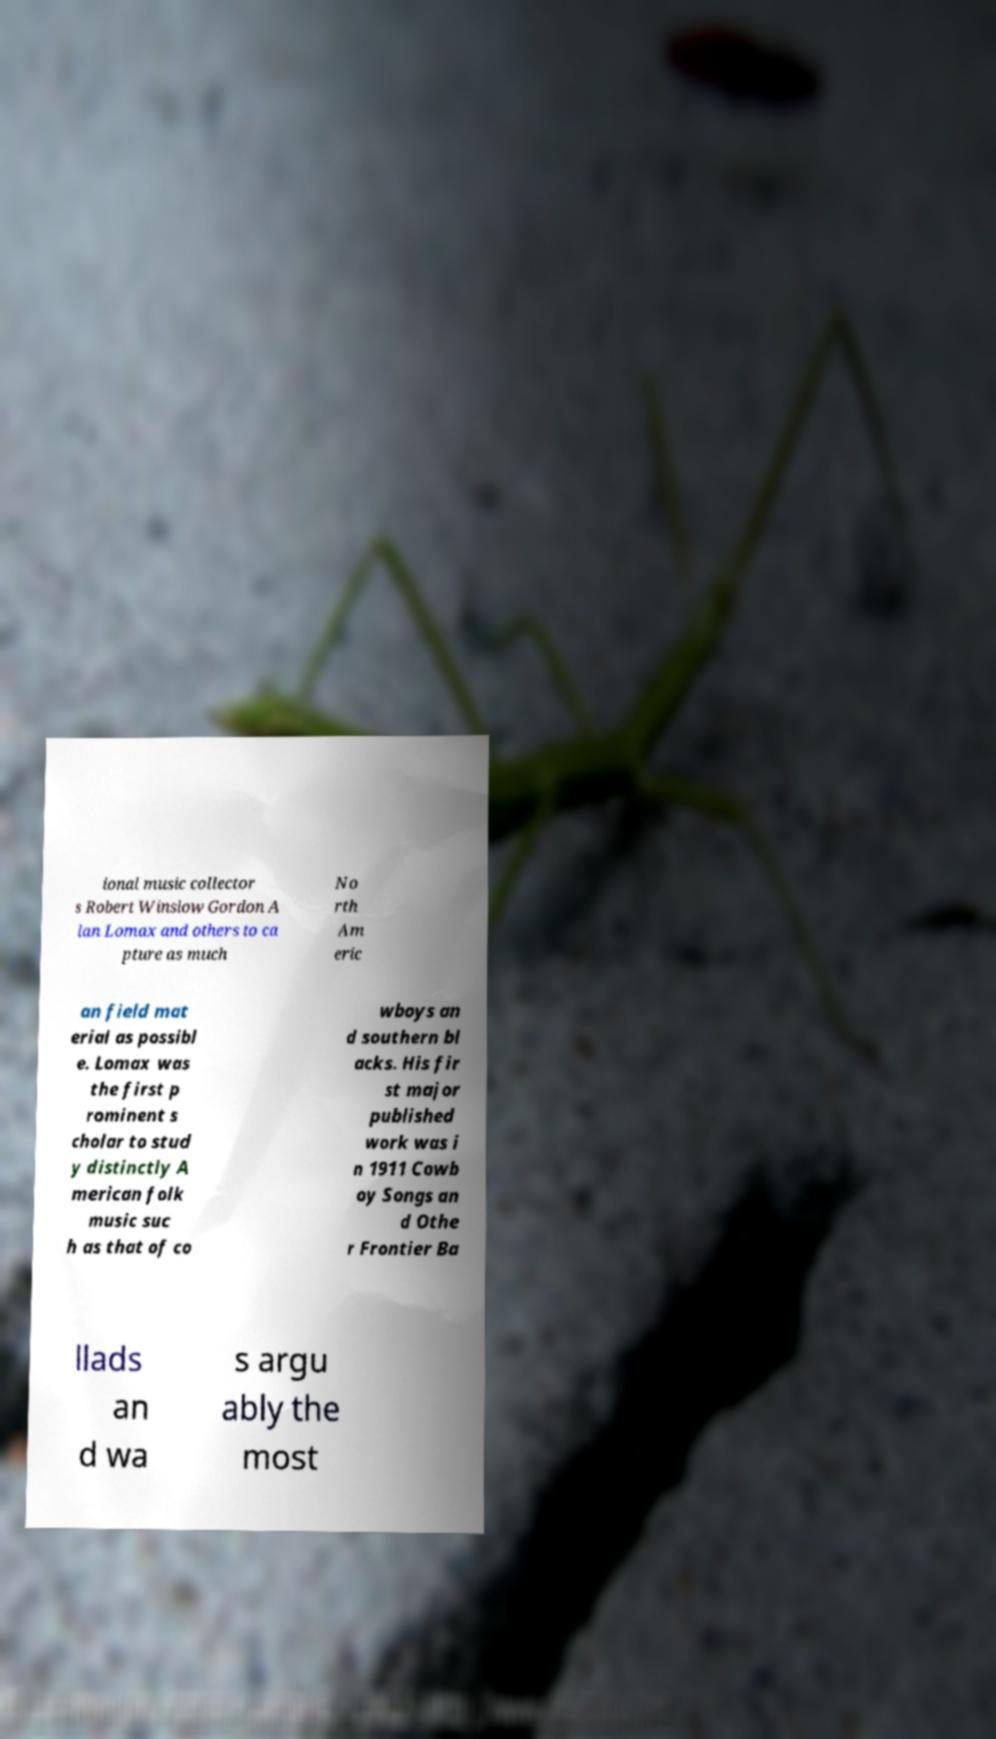Please identify and transcribe the text found in this image. ional music collector s Robert Winslow Gordon A lan Lomax and others to ca pture as much No rth Am eric an field mat erial as possibl e. Lomax was the first p rominent s cholar to stud y distinctly A merican folk music suc h as that of co wboys an d southern bl acks. His fir st major published work was i n 1911 Cowb oy Songs an d Othe r Frontier Ba llads an d wa s argu ably the most 